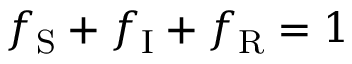Convert formula to latex. <formula><loc_0><loc_0><loc_500><loc_500>f _ { S } + f _ { I } + f _ { R } = 1</formula> 